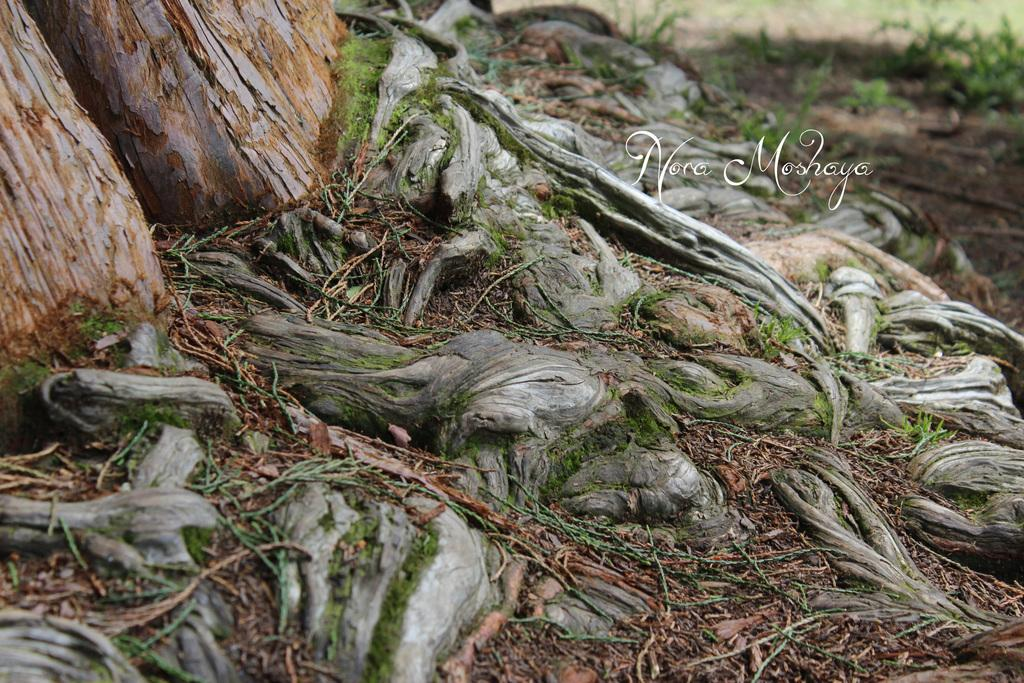What type of vegetation is present in the image? There are tree trunks and grass visible in the image. What else can be seen in the image besides vegetation? There is a poster with text written on it in the image. How many horses are visible in the image? There are no horses present in the image. What type of grip is required to read the text on the poster? The image does not provide information about the grip required to read the text on the poster, as it only shows the poster with text written on it. 